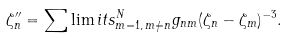Convert formula to latex. <formula><loc_0><loc_0><loc_500><loc_500>\zeta ^ { \prime \prime } _ { n } = \sum \lim i t s _ { m = 1 , \, m \ne n } ^ { N } g _ { n m } ( \zeta _ { n } - \zeta _ { m } ) ^ { - 3 } .</formula> 